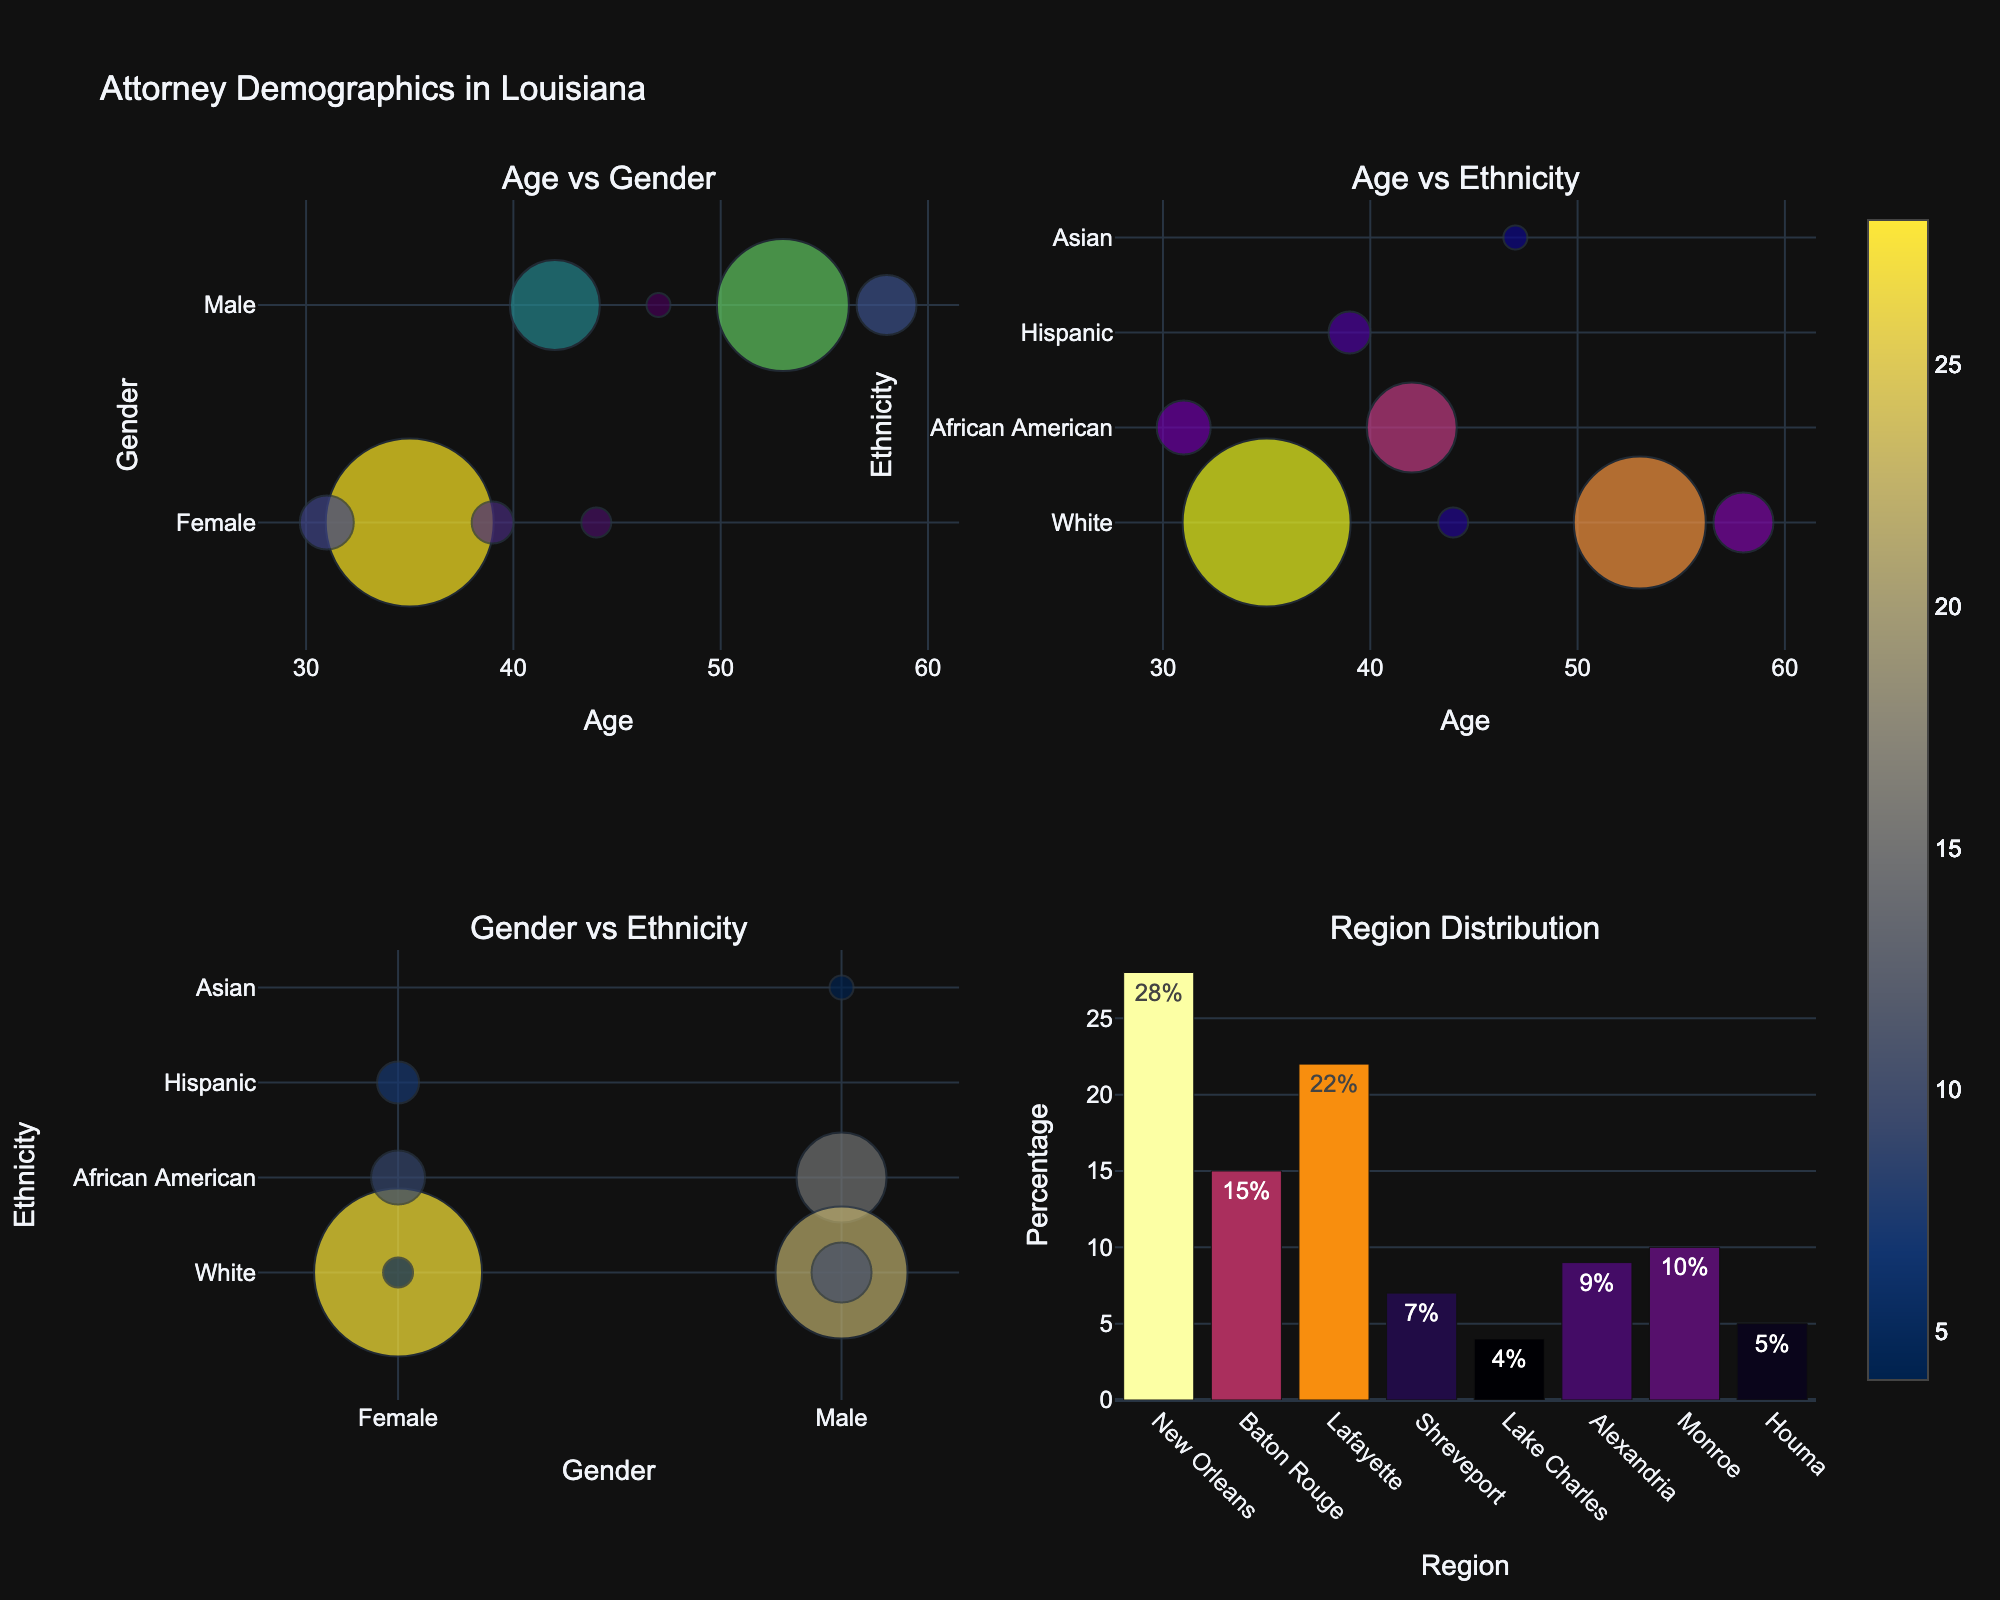What's the title of the plot? The title of the plot is displayed at the top of the figure. It provides an overview of what the entire figure represents.
Answer: Attorney Demographics in Louisiana Which region has the highest percentage of attorneys? Check the bar chart located in the bottom right of the figure. Look for the bar that extends the furthest along the vertical axis.
Answer: New Orleans How does the percentage of White male attorneys compare to White female attorneys? Examine the scatter plots in rows 1 and 2. Identify the sizes of the bubbles corresponding to White male and White female attorneys, as the bubble size represents the percentage. The male bubbles are comparatively larger.
Answer: White male attorneys have a higher percentage What's the average age of female attorneys? Locate all bubbles in the scatter plots that are categorized as "Female." Note their ages and calculate the average: (35 + 39 + 31 + 44) / 4.
Answer: 37.25 What is the gender distribution briefly summarized from the figure? By observing the number of bubbles marked as "Male" and "Female" in the Age vs. Gender and Gender vs. Ethnicity plots, count the occurrences of each gender.
Answer: More male attorneys than female Which ethnicity group is least represented among attorneys in Louisiana? Check the scatter plots and notice the smallest bubbles, indicating the least percentage. The Asian ethnic group has the smallest bubble.
Answer: Asian What's the range of ages among White attorneys? Locate the ages of White attorneys from the Age vs. Gender and Age vs. Ethnicity plots. The ages are 35, 53, 58, and 44. Subtract the smallest age from the largest: 58 - 35.
Answer: 23 years Which gender has a wider range of ages? Identify the age ranges for male and female attorneys from the Age vs. Gender plot. For males: 42 (youngest) to 58 (oldest); For females: 31 (youngest) to 44 (oldest). Calculate the difference for both ranges.
Answer: Male Is there any overlap in the ages at which female and male attorneys are most commonly represented? Compare the ages seen in the Age vs. Gender scatter plot for both genders. Check for common ages. Both genders have attorneys aged around the 40s.
Answer: Yes How many ethnicities are represented in the plot? Review the Ethnicity axis in the Age vs. Ethnicity and Gender vs. Ethnicity plots. Count distinct ethnic categories shown.
Answer: 4 